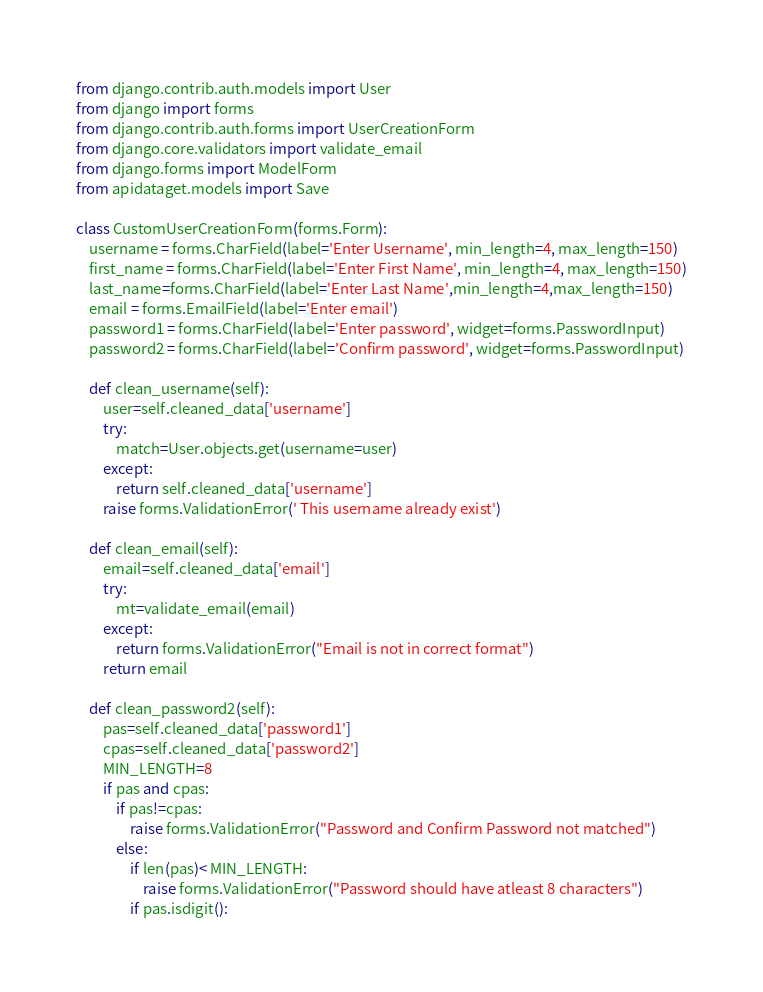Convert code to text. <code><loc_0><loc_0><loc_500><loc_500><_Python_>from django.contrib.auth.models import User
from django import forms
from django.contrib.auth.forms import UserCreationForm
from django.core.validators import validate_email
from django.forms import ModelForm
from apidataget.models import Save

class CustomUserCreationForm(forms.Form):
    username = forms.CharField(label='Enter Username', min_length=4, max_length=150)
    first_name = forms.CharField(label='Enter First Name', min_length=4, max_length=150)
    last_name=forms.CharField(label='Enter Last Name',min_length=4,max_length=150)
    email = forms.EmailField(label='Enter email')
    password1 = forms.CharField(label='Enter password', widget=forms.PasswordInput)
    password2 = forms.CharField(label='Confirm password', widget=forms.PasswordInput)

    def clean_username(self):
        user=self.cleaned_data['username']
        try:
            match=User.objects.get(username=user)
        except:
            return self.cleaned_data['username']
        raise forms.ValidationError(' This username already exist')

    def clean_email(self):
        email=self.cleaned_data['email']
        try:
            mt=validate_email(email)
        except:
            return forms.ValidationError("Email is not in correct format")
        return email

    def clean_password2(self):
        pas=self.cleaned_data['password1']
        cpas=self.cleaned_data['password2']
        MIN_LENGTH=8
        if pas and cpas:
            if pas!=cpas:
                raise forms.ValidationError("Password and Confirm Password not matched")
            else:
                if len(pas)< MIN_LENGTH:
                    raise forms.ValidationError("Password should have atleast 8 characters")
                if pas.isdigit():</code> 